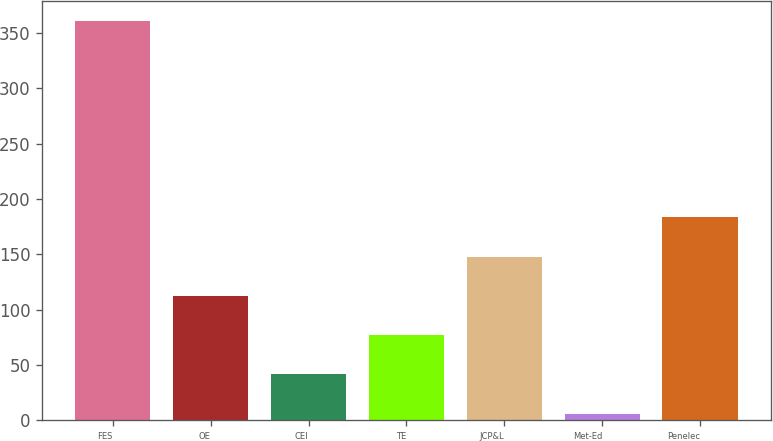<chart> <loc_0><loc_0><loc_500><loc_500><bar_chart><fcel>FES<fcel>OE<fcel>CEI<fcel>TE<fcel>JCP&L<fcel>Met-Ed<fcel>Penelec<nl><fcel>361<fcel>112.5<fcel>41.5<fcel>77<fcel>148<fcel>6<fcel>183.5<nl></chart> 